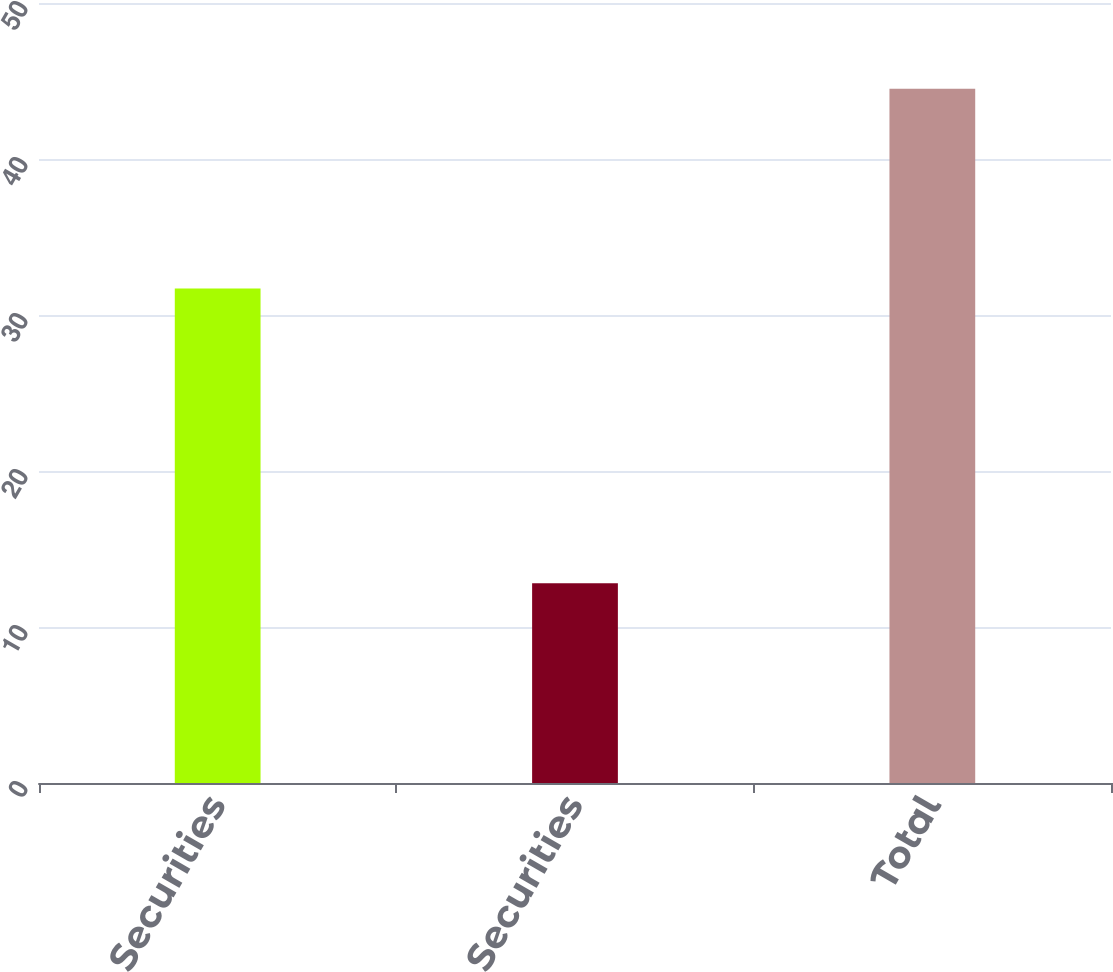Convert chart. <chart><loc_0><loc_0><loc_500><loc_500><bar_chart><fcel>Equity Securities<fcel>Debt Securities<fcel>Total<nl><fcel>31.7<fcel>12.8<fcel>44.5<nl></chart> 